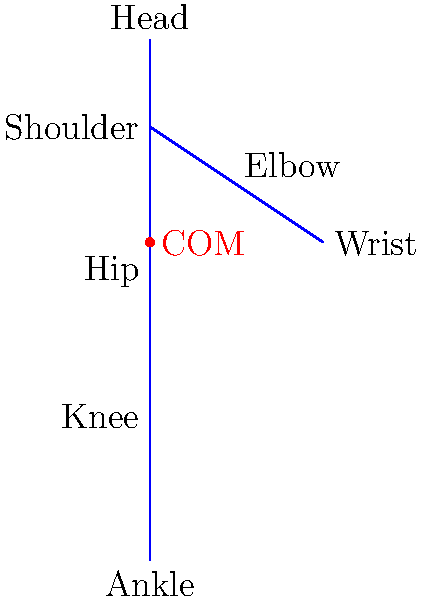In software architecture documentation for biomechanics applications, it's essential to understand how to estimate the center of mass (COM) of a human body. Using the simplified body segment model shown in the figure, where would you estimate the COM of the human body in this standing posture? Express your answer as a percentage of total body height from the ground. To estimate the center of mass (COM) of a human body using a simplified body segment model, we can follow these steps:

1. Identify the major body segments: In this case, we have the head, trunk, upper arms, forearms, thighs, and lower legs.

2. Estimate the relative mass of each segment as a percentage of total body mass:
   - Head: 8%
   - Trunk (including neck): 50%
   - Upper arms (each): 3%
   - Forearms (each): 2%
   - Thighs (each): 10%
   - Lower legs (each): 6%

3. Estimate the location of each segment's COM relative to the proximal joint:
   - Head: 50% of segment length from top of head
   - Trunk: 50% of segment length from shoulder
   - Upper arms: 44% of segment length from shoulder
   - Forearms: 43% of segment length from elbow
   - Thighs: 43% of segment length from hip
   - Lower legs: 43% of segment length from knee

4. Calculate the weighted average of these positions:
   Let's assume the total height is 180 cm (from ankle to top of head).
   
   Head: 8% * (180 - 15) = 13.2 cm contribution
   Trunk: 50% * (165 / 2 + 15) = 48.75 cm contribution
   Upper arms: 2 * 3% * (150 - 20) = 7.8 cm contribution
   Forearms: 2 * 2% * (130 - 40) = 3.6 cm contribution
   Thighs: 2 * 10% * (100 / 2) = 10 cm contribution
   Lower legs: 2 * 6% * (50 / 2) = 3 cm contribution

   Total contribution: 86.35 cm

5. The estimated COM location is therefore at approximately 86.35 cm from the ground.

6. Express this as a percentage of total body height:
   (86.35 / 180) * 100 ≈ 48%

Therefore, the COM is estimated to be at approximately 48% of total body height from the ground.
Answer: 48% of total body height from the ground 